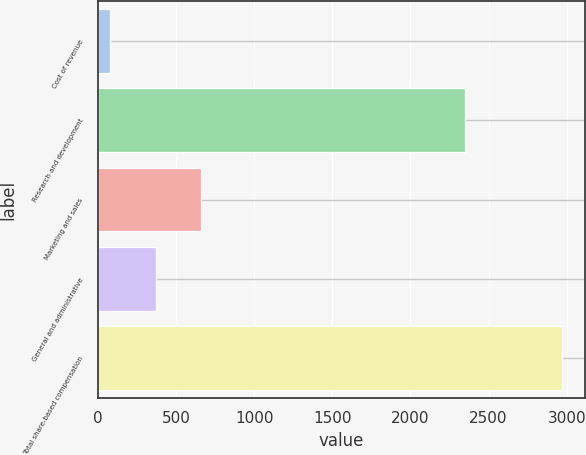Convert chart. <chart><loc_0><loc_0><loc_500><loc_500><bar_chart><fcel>Cost of revenue<fcel>Research and development<fcel>Marketing and sales<fcel>General and administrative<fcel>Total share-based compensation<nl><fcel>81<fcel>2350<fcel>658.6<fcel>369.8<fcel>2969<nl></chart> 